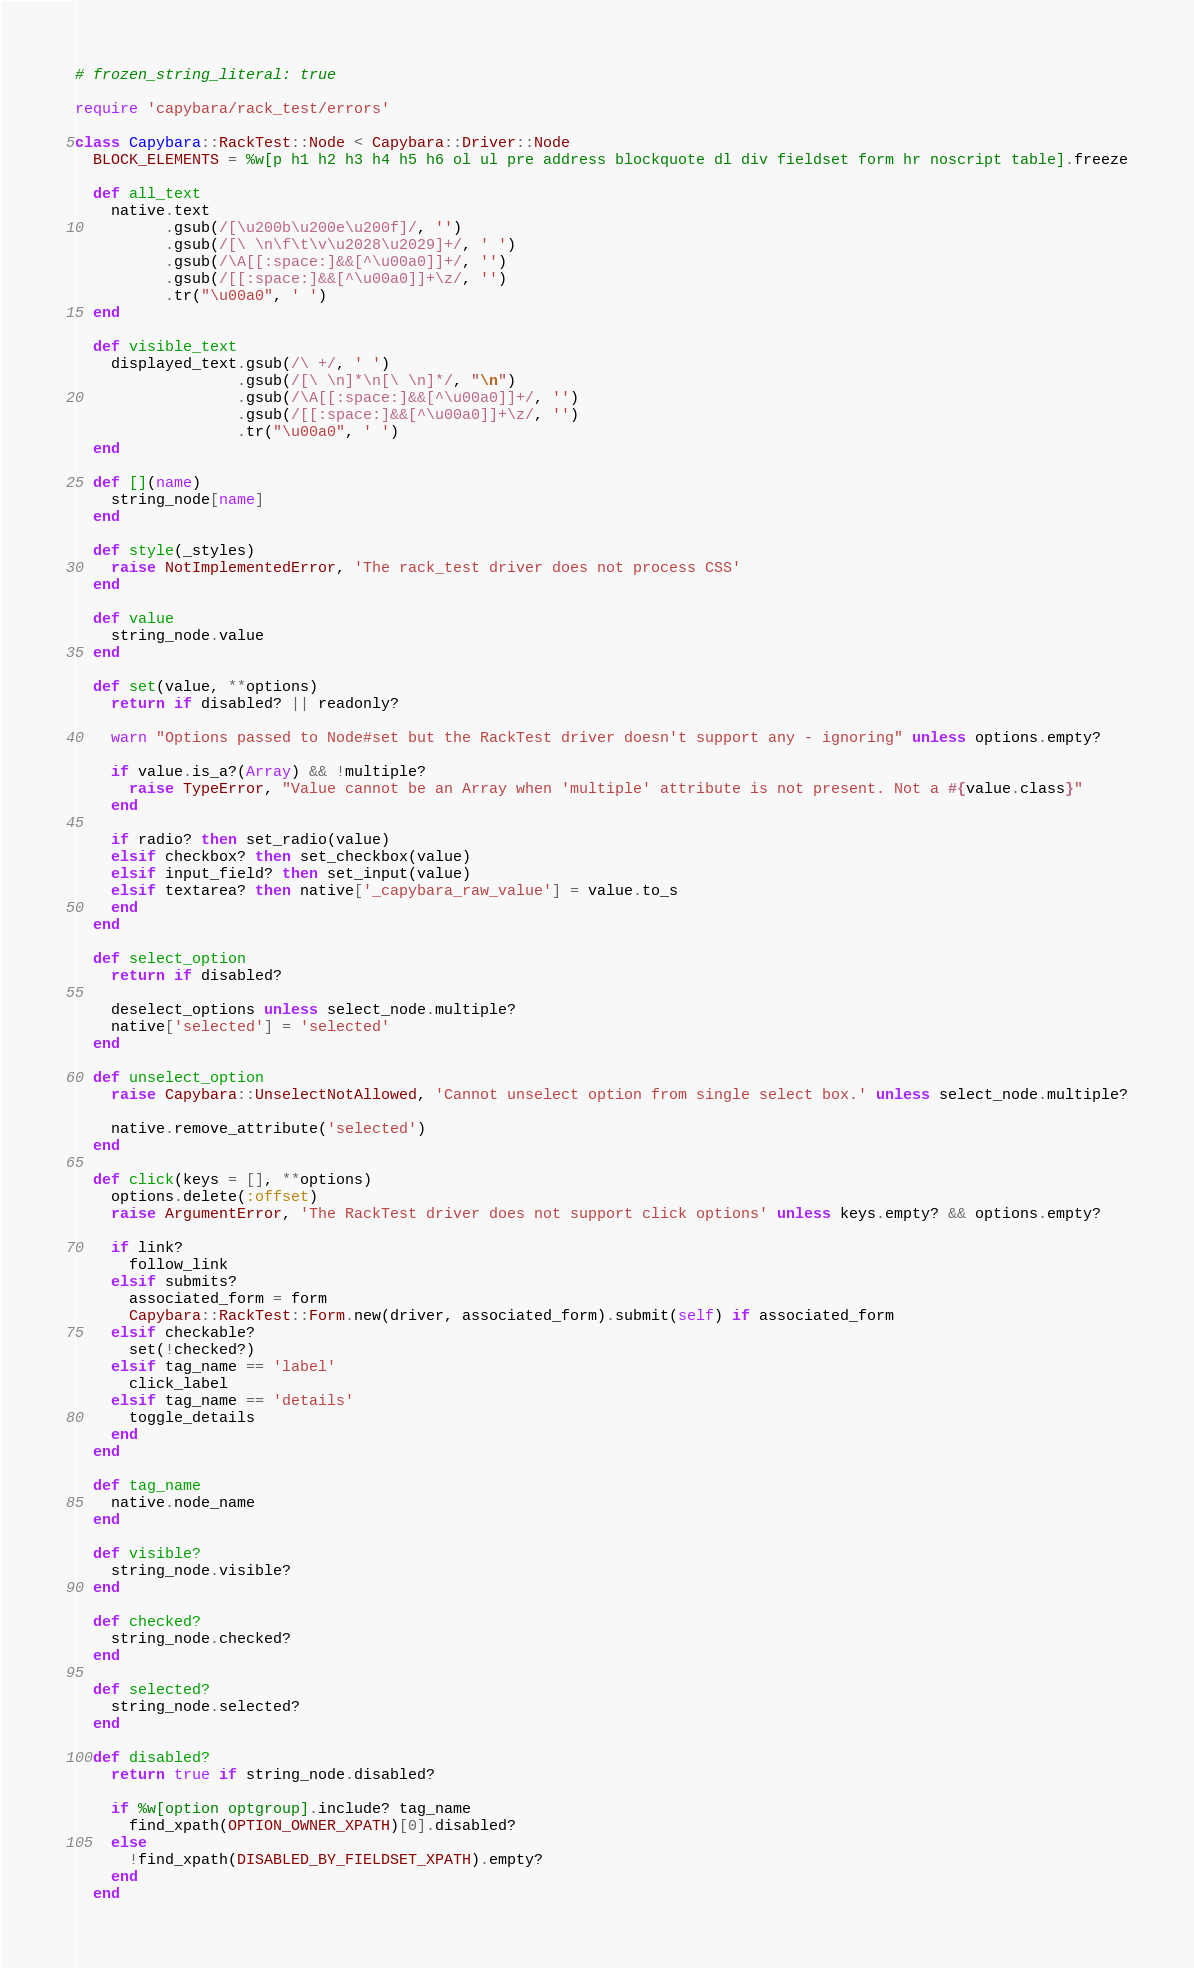<code> <loc_0><loc_0><loc_500><loc_500><_Ruby_># frozen_string_literal: true

require 'capybara/rack_test/errors'

class Capybara::RackTest::Node < Capybara::Driver::Node
  BLOCK_ELEMENTS = %w[p h1 h2 h3 h4 h5 h6 ol ul pre address blockquote dl div fieldset form hr noscript table].freeze

  def all_text
    native.text
          .gsub(/[\u200b\u200e\u200f]/, '')
          .gsub(/[\ \n\f\t\v\u2028\u2029]+/, ' ')
          .gsub(/\A[[:space:]&&[^\u00a0]]+/, '')
          .gsub(/[[:space:]&&[^\u00a0]]+\z/, '')
          .tr("\u00a0", ' ')
  end

  def visible_text
    displayed_text.gsub(/\ +/, ' ')
                  .gsub(/[\ \n]*\n[\ \n]*/, "\n")
                  .gsub(/\A[[:space:]&&[^\u00a0]]+/, '')
                  .gsub(/[[:space:]&&[^\u00a0]]+\z/, '')
                  .tr("\u00a0", ' ')
  end

  def [](name)
    string_node[name]
  end

  def style(_styles)
    raise NotImplementedError, 'The rack_test driver does not process CSS'
  end

  def value
    string_node.value
  end

  def set(value, **options)
    return if disabled? || readonly?

    warn "Options passed to Node#set but the RackTest driver doesn't support any - ignoring" unless options.empty?

    if value.is_a?(Array) && !multiple?
      raise TypeError, "Value cannot be an Array when 'multiple' attribute is not present. Not a #{value.class}"
    end

    if radio? then set_radio(value)
    elsif checkbox? then set_checkbox(value)
    elsif input_field? then set_input(value)
    elsif textarea? then native['_capybara_raw_value'] = value.to_s
    end
  end

  def select_option
    return if disabled?

    deselect_options unless select_node.multiple?
    native['selected'] = 'selected'
  end

  def unselect_option
    raise Capybara::UnselectNotAllowed, 'Cannot unselect option from single select box.' unless select_node.multiple?

    native.remove_attribute('selected')
  end

  def click(keys = [], **options)
    options.delete(:offset)
    raise ArgumentError, 'The RackTest driver does not support click options' unless keys.empty? && options.empty?

    if link?
      follow_link
    elsif submits?
      associated_form = form
      Capybara::RackTest::Form.new(driver, associated_form).submit(self) if associated_form
    elsif checkable?
      set(!checked?)
    elsif tag_name == 'label'
      click_label
    elsif tag_name == 'details'
      toggle_details
    end
  end

  def tag_name
    native.node_name
  end

  def visible?
    string_node.visible?
  end

  def checked?
    string_node.checked?
  end

  def selected?
    string_node.selected?
  end

  def disabled?
    return true if string_node.disabled?

    if %w[option optgroup].include? tag_name
      find_xpath(OPTION_OWNER_XPATH)[0].disabled?
    else
      !find_xpath(DISABLED_BY_FIELDSET_XPATH).empty?
    end
  end
</code> 